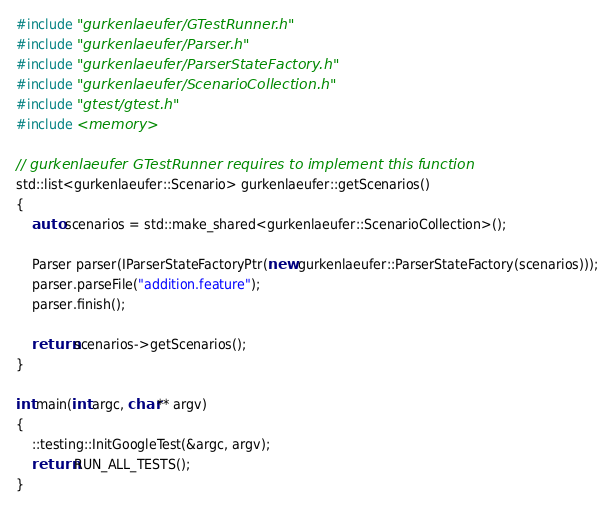Convert code to text. <code><loc_0><loc_0><loc_500><loc_500><_C++_>#include "gurkenlaeufer/GTestRunner.h"
#include "gurkenlaeufer/Parser.h"
#include "gurkenlaeufer/ParserStateFactory.h"
#include "gurkenlaeufer/ScenarioCollection.h"
#include "gtest/gtest.h"
#include <memory>

// gurkenlaeufer GTestRunner requires to implement this function
std::list<gurkenlaeufer::Scenario> gurkenlaeufer::getScenarios()
{
    auto scenarios = std::make_shared<gurkenlaeufer::ScenarioCollection>();

    Parser parser(IParserStateFactoryPtr(new gurkenlaeufer::ParserStateFactory(scenarios)));
    parser.parseFile("addition.feature");
    parser.finish();

    return scenarios->getScenarios();
}

int main(int argc, char** argv)
{
    ::testing::InitGoogleTest(&argc, argv);
    return RUN_ALL_TESTS();
}
</code> 